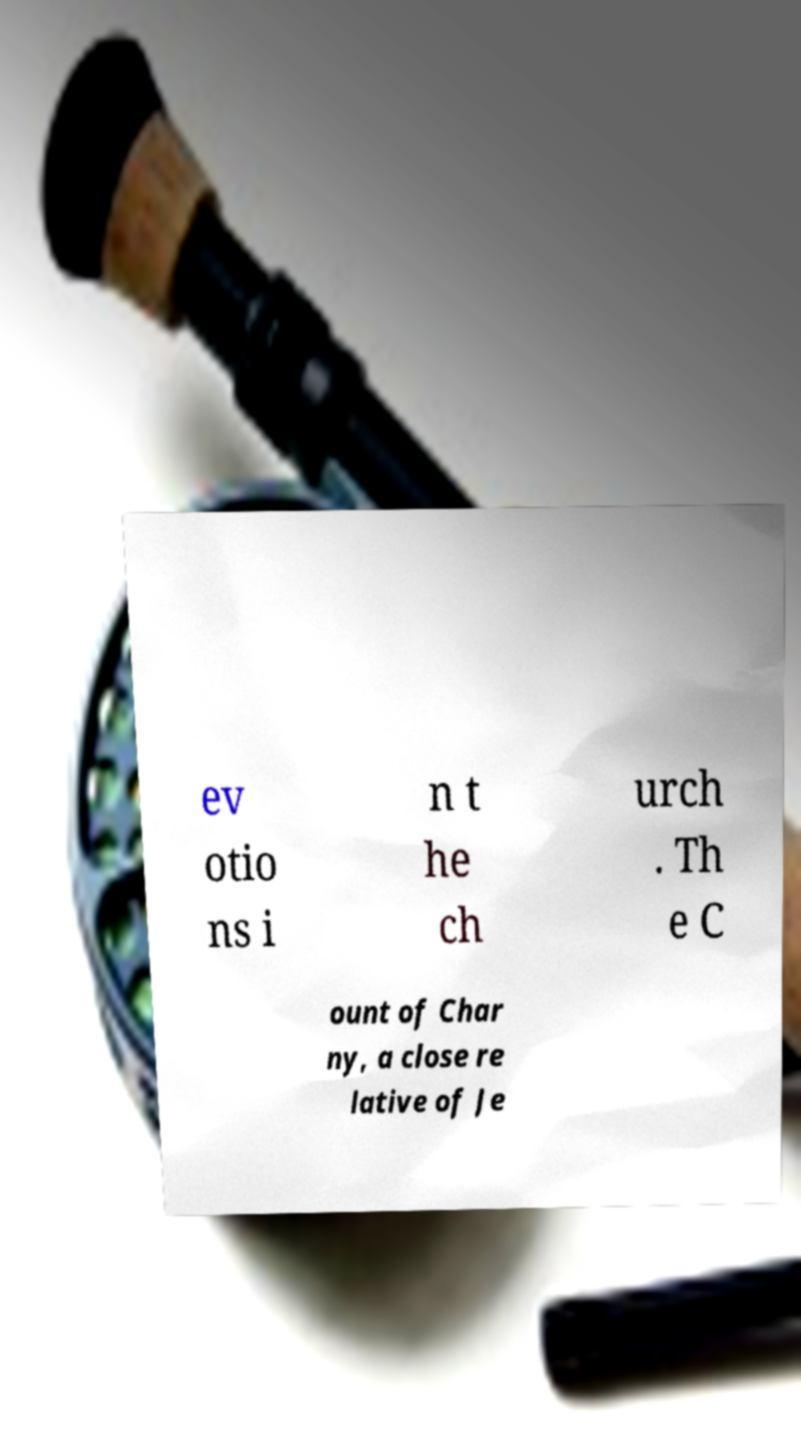I need the written content from this picture converted into text. Can you do that? ev otio ns i n t he ch urch . Th e C ount of Char ny, a close re lative of Je 